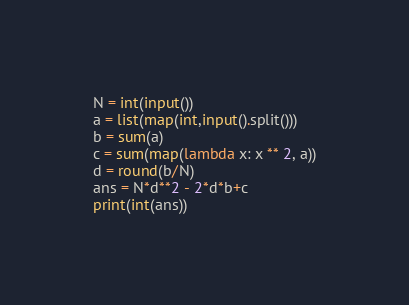Convert code to text. <code><loc_0><loc_0><loc_500><loc_500><_Python_>N = int(input())
a = list(map(int,input().split()))
b = sum(a)
c = sum(map(lambda x: x ** 2, a))
d = round(b/N) 
ans = N*d**2 - 2*d*b+c
print(int(ans))</code> 